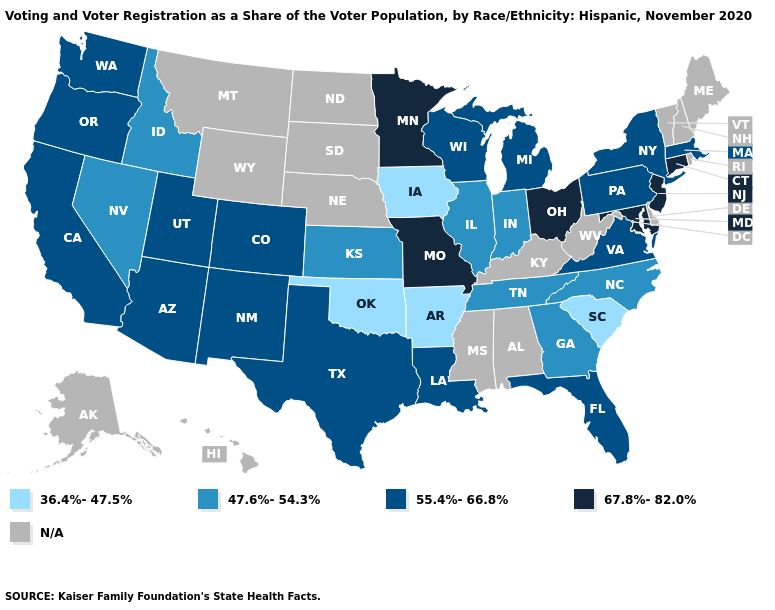Name the states that have a value in the range N/A?
Short answer required. Alabama, Alaska, Delaware, Hawaii, Kentucky, Maine, Mississippi, Montana, Nebraska, New Hampshire, North Dakota, Rhode Island, South Dakota, Vermont, West Virginia, Wyoming. Name the states that have a value in the range N/A?
Be succinct. Alabama, Alaska, Delaware, Hawaii, Kentucky, Maine, Mississippi, Montana, Nebraska, New Hampshire, North Dakota, Rhode Island, South Dakota, Vermont, West Virginia, Wyoming. What is the lowest value in the Northeast?
Answer briefly. 55.4%-66.8%. Among the states that border Arizona , which have the lowest value?
Write a very short answer. Nevada. Does Missouri have the highest value in the MidWest?
Keep it brief. Yes. What is the value of Oklahoma?
Keep it brief. 36.4%-47.5%. Name the states that have a value in the range N/A?
Write a very short answer. Alabama, Alaska, Delaware, Hawaii, Kentucky, Maine, Mississippi, Montana, Nebraska, New Hampshire, North Dakota, Rhode Island, South Dakota, Vermont, West Virginia, Wyoming. What is the value of Iowa?
Quick response, please. 36.4%-47.5%. What is the highest value in the Northeast ?
Short answer required. 67.8%-82.0%. Among the states that border Rhode Island , does Connecticut have the highest value?
Give a very brief answer. Yes. Name the states that have a value in the range 67.8%-82.0%?
Answer briefly. Connecticut, Maryland, Minnesota, Missouri, New Jersey, Ohio. Does Iowa have the lowest value in the MidWest?
Keep it brief. Yes. Name the states that have a value in the range 47.6%-54.3%?
Answer briefly. Georgia, Idaho, Illinois, Indiana, Kansas, Nevada, North Carolina, Tennessee. Which states have the lowest value in the South?
Write a very short answer. Arkansas, Oklahoma, South Carolina. Name the states that have a value in the range 67.8%-82.0%?
Write a very short answer. Connecticut, Maryland, Minnesota, Missouri, New Jersey, Ohio. 